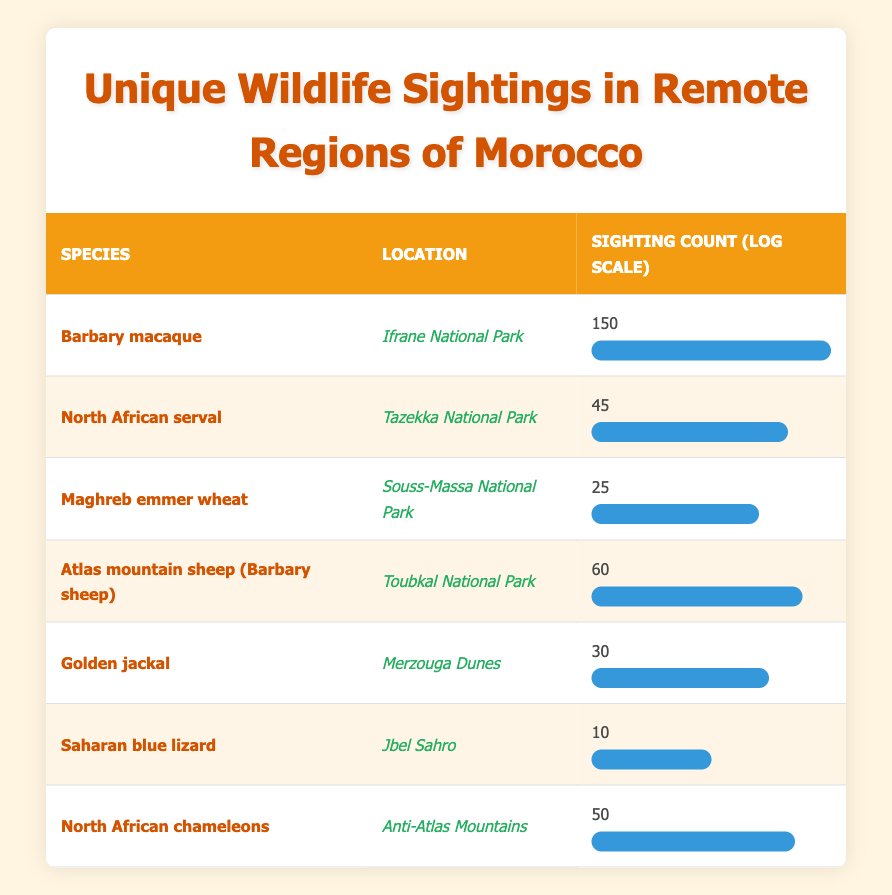What is the species with the highest sighting count? The table shows the sighting count for each species. The Barbary macaque has a sighting count of 150, which is the highest among all species listed.
Answer: Barbary macaque Which location had the least wildlife sightings? By examining the sighting counts of each species, the Saharan blue lizard is reported to have the least sightings, with a count of 10 in Jbel Sahro.
Answer: Jbel Sahro How many sightings are there in total across all species? To find the total number of sightings, we sum the sighting counts for all species: 150 + 45 + 25 + 60 + 30 + 10 + 50 = 370.
Answer: 370 Is it true that North African servals have more sightings than Golden jackals? The North African serval has 45 sightings, while Golden jackals have 30 sightings. Therefore, it's true that North African servals have more sightings.
Answer: Yes What is the average sighting count for the wildlife species listed in the table? We first sum the total sightings (370) as calculated earlier. There are 7 species listed, so we calculate the average by dividing the total sightings by the number of species: 370/7 = 52.86 (approximately).
Answer: 52.86 Which species has a sighting count closest to the median value of the sightings? To find the median, we arrange the sighting counts in order: 10, 25, 30, 45, 50, 60, 150. The median is the middle value, which is 45. The species that matches this count is the North African serval, which has a sighting count of 45.
Answer: North African serval Is there a species with a sighting count that is a multiple of 10? Checking the sighting counts, all species except the Maghreb emmer wheat (25) and North African serval (45) have sighting counts that are multiples of 10. Thus, there are species with counts that are multiples of 10.
Answer: Yes What is the difference in sighting counts between the species with the highest and the lowest values? The highest sighting count is for the Barbary macaque at 150, and the lowest is the Saharan blue lizard at 10. The difference is calculated as 150 - 10 = 140.
Answer: 140 